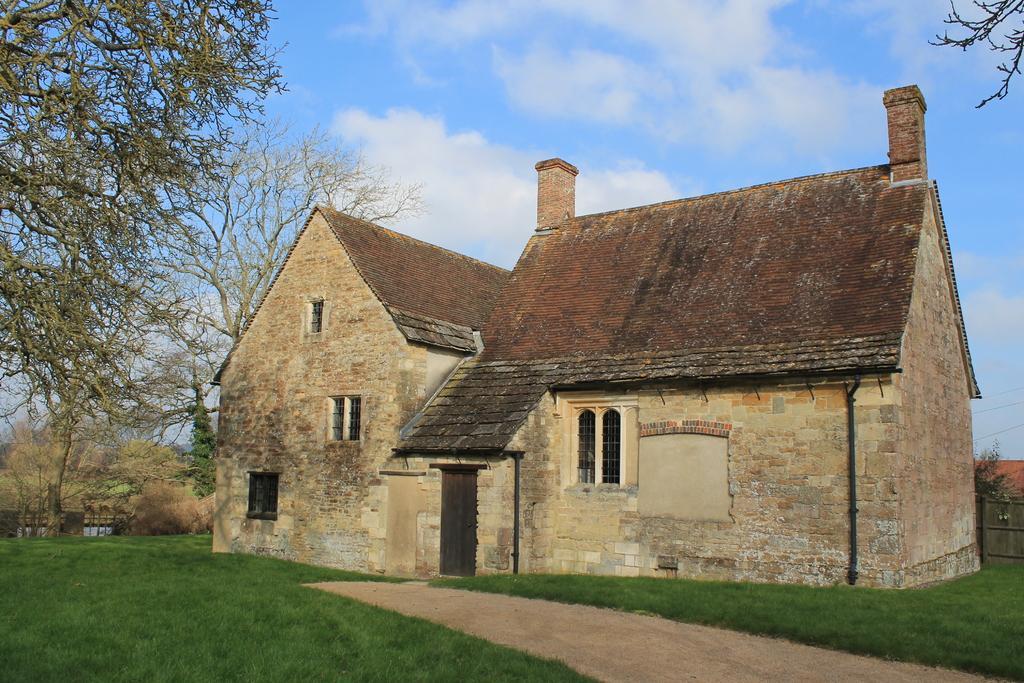Could you give a brief overview of what you see in this image? In this image we can see many trees. We can see a house and it is having few windows. There is a walkway in the image. There is a fence at the either sides of the image. There is a grassy land in the image. We can see the clouds in the sky. 